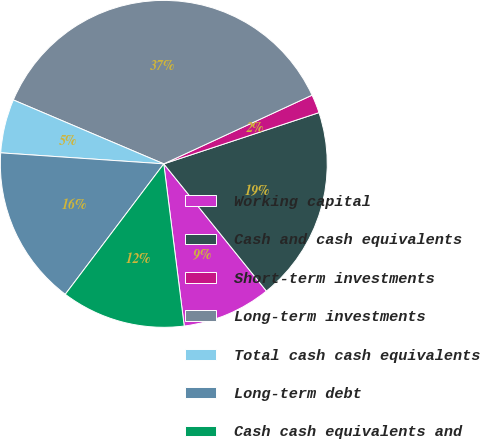Convert chart to OTSL. <chart><loc_0><loc_0><loc_500><loc_500><pie_chart><fcel>Working capital<fcel>Cash and cash equivalents<fcel>Short-term investments<fcel>Long-term investments<fcel>Total cash cash equivalents<fcel>Long-term debt<fcel>Cash cash equivalents and<nl><fcel>8.81%<fcel>19.27%<fcel>1.83%<fcel>36.7%<fcel>5.32%<fcel>15.78%<fcel>12.29%<nl></chart> 